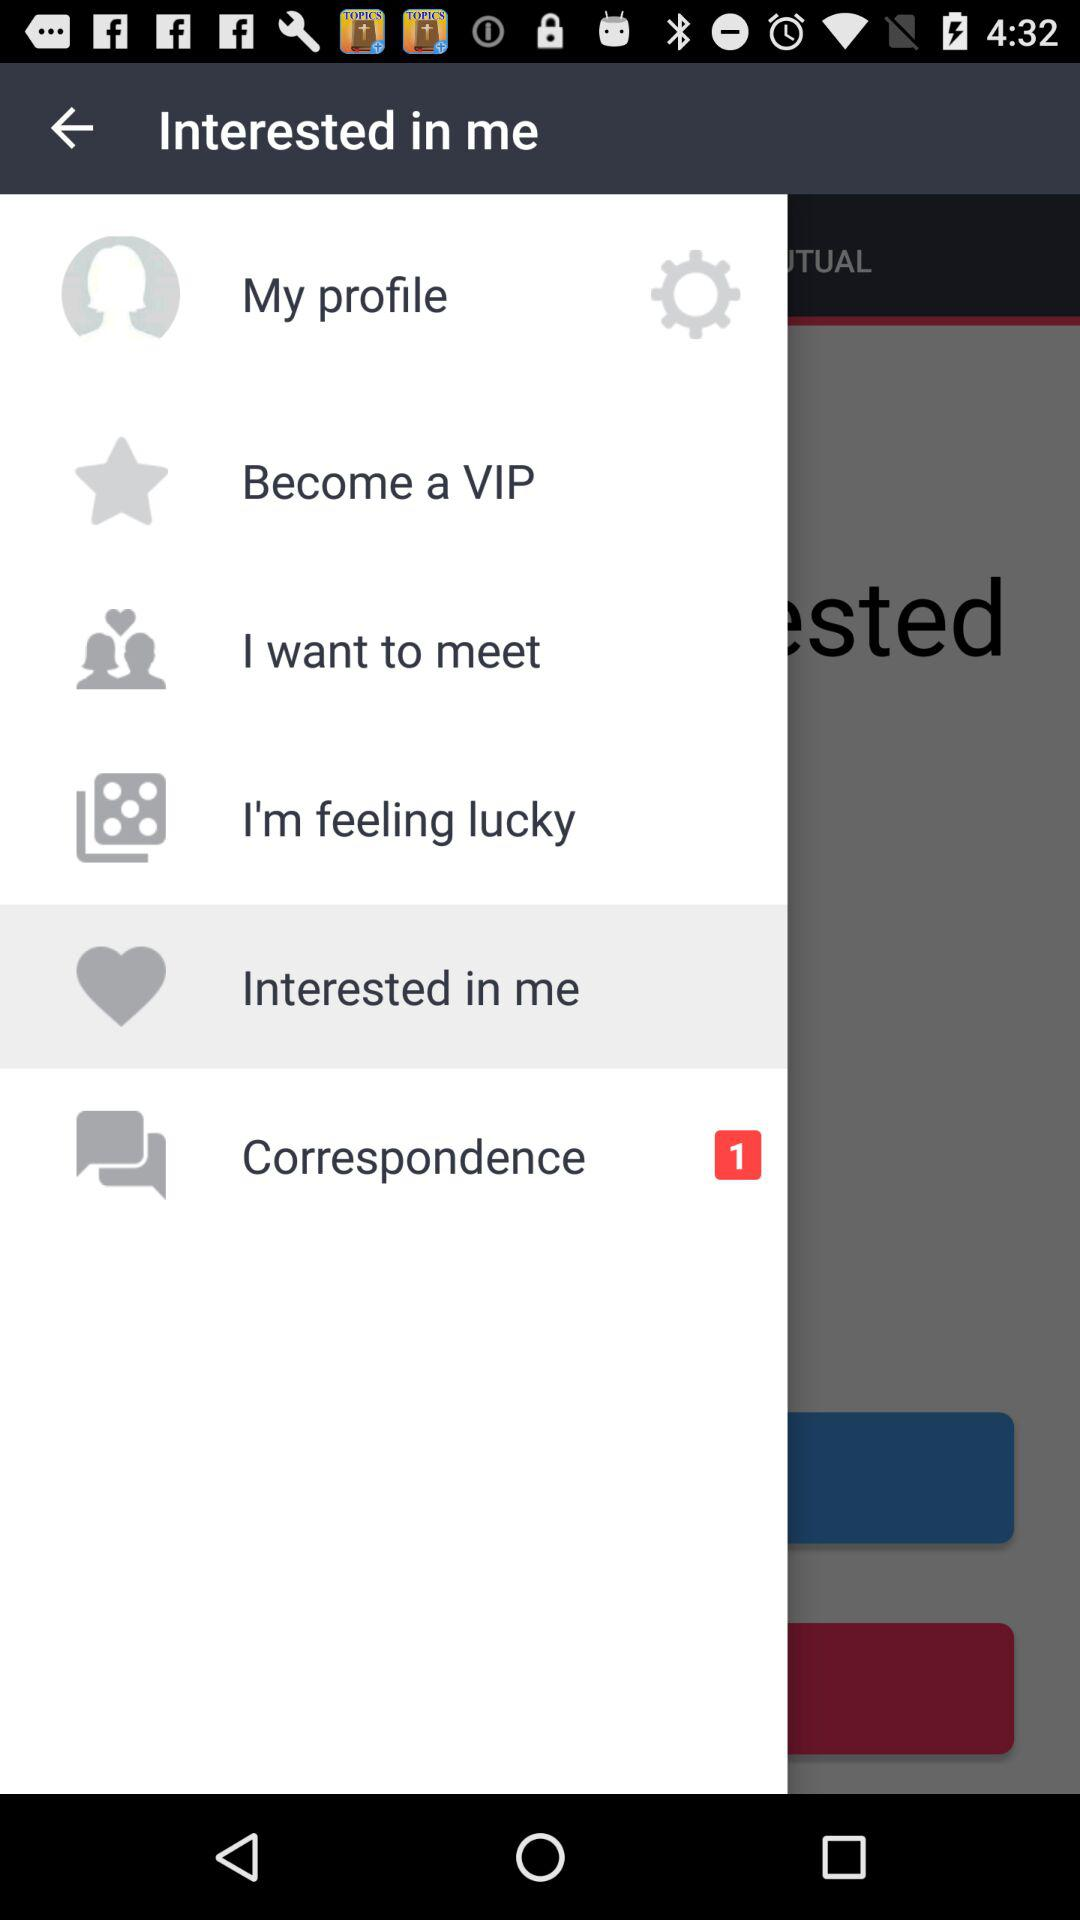How many unread correspondence messages are there? There is 1 unread correspondence message. 